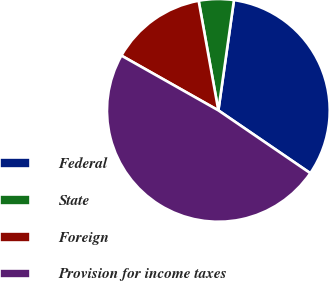Convert chart. <chart><loc_0><loc_0><loc_500><loc_500><pie_chart><fcel>Federal<fcel>State<fcel>Foreign<fcel>Provision for income taxes<nl><fcel>32.3%<fcel>5.07%<fcel>13.98%<fcel>48.64%<nl></chart> 